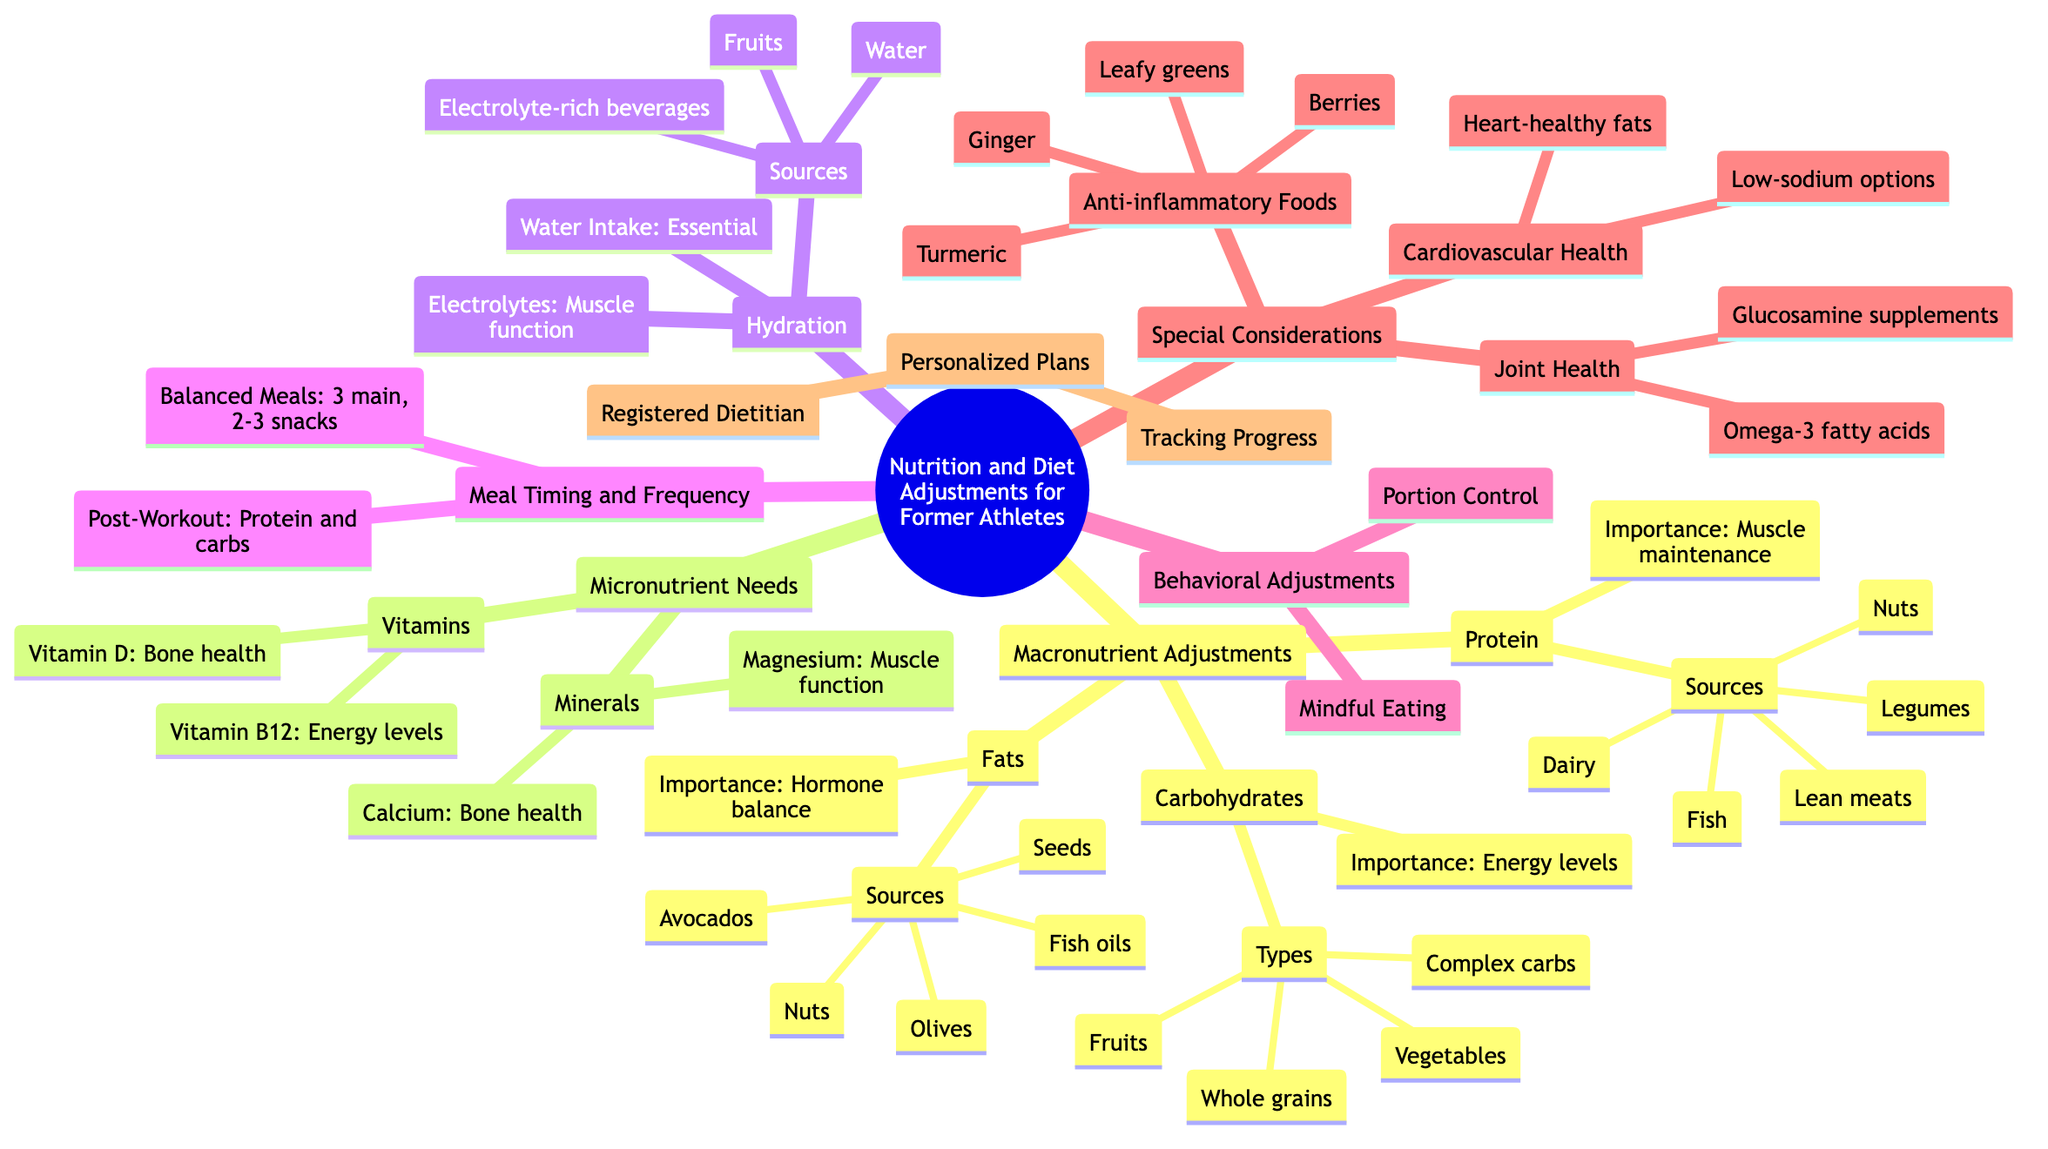What are the three main macronutrients? The diagram lists three categories under "Macronutrient Adjustments," which are "Protein," "Carbohydrates," and "Fats."
Answer: Protein, Carbohydrates, Fats What is the importance of protein for former athletes? The diagram states that the importance of protein is "Muscle maintenance and repair."
Answer: Muscle maintenance and repair How many sources of protein are mentioned? Under the "Protein" section, there are five sources listed: "Lean meats," "Fish," "Legumes," "Nuts," and "Dairy."
Answer: 5 What type of meals are recommended for meal timing? The diagram indicates that "Balanced Meals" consist of "3 main meals with 2-3 snacks."
Answer: 3 main meals with 2-3 snacks What are two examples of anti-inflammatory foods? The "Special Considerations" section lists four anti-inflammatory foods, and two examples from these are "Turmeric" and "Ginger."
Answer: Turmeric, Ginger Which micronutrient supports energy levels and nerve function? The diagram specifies "Vitamin B12" as essential for "Energy levels and nerve function."
Answer: Vitamin B12 How should post-workout meals be composed? The diagram advises that post-workout meals should include "Protein and carbs within 30 minutes after exercise."
Answer: Protein and carbs Which professional is suggested for tailored dietary advice? The "Personalized Plans" section recommends consulting a "Registered Dietitian" for personalized dietary advice.
Answer: Registered Dietitian What is recommended for hydration in terms of sources? The "Hydration" section lists sources including "Water," "Electrolyte-rich beverages," and "Fruits." Any one will suffice.
Answer: Water, Electrolyte-rich beverages, Fruits 